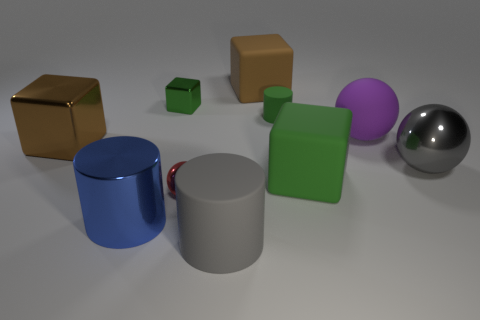Subtract all blue balls. Subtract all yellow cylinders. How many balls are left? 3 Subtract all cylinders. How many objects are left? 7 Add 7 large shiny balls. How many large shiny balls exist? 8 Subtract 1 green cylinders. How many objects are left? 9 Subtract all tiny yellow cylinders. Subtract all small matte cylinders. How many objects are left? 9 Add 8 green metallic cubes. How many green metallic cubes are left? 9 